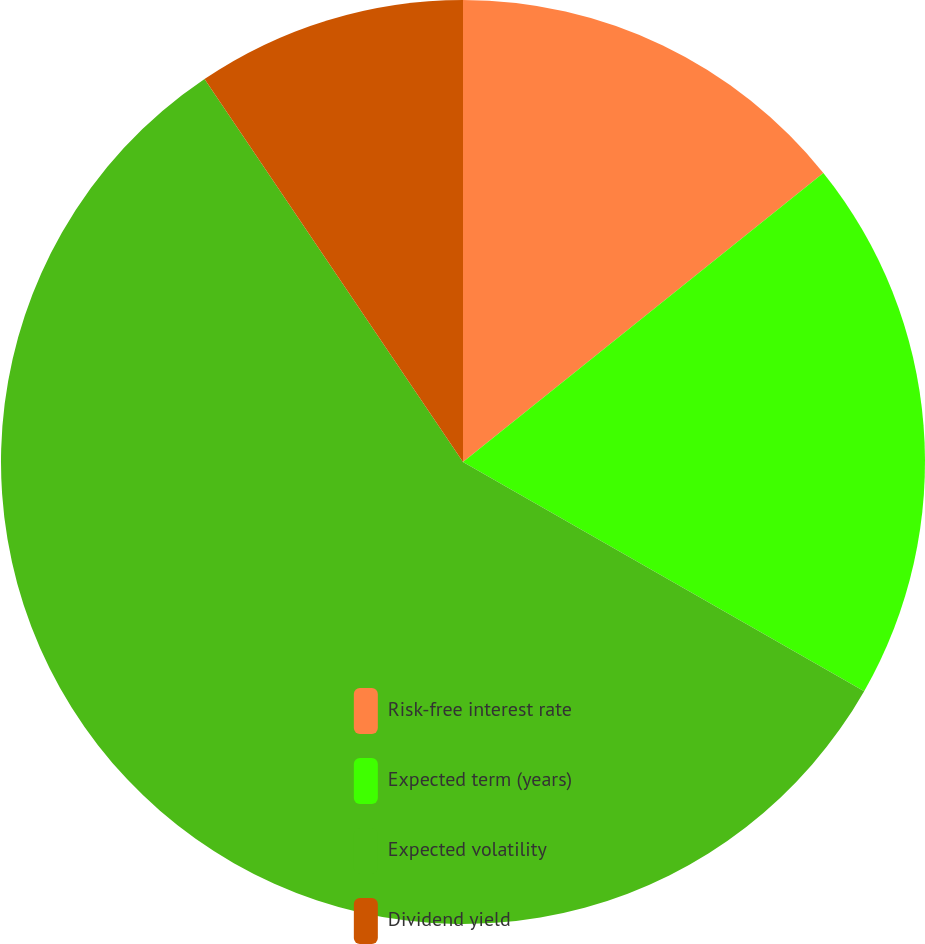<chart> <loc_0><loc_0><loc_500><loc_500><pie_chart><fcel>Risk-free interest rate<fcel>Expected term (years)<fcel>Expected volatility<fcel>Dividend yield<nl><fcel>14.24%<fcel>19.02%<fcel>57.29%<fcel>9.45%<nl></chart> 